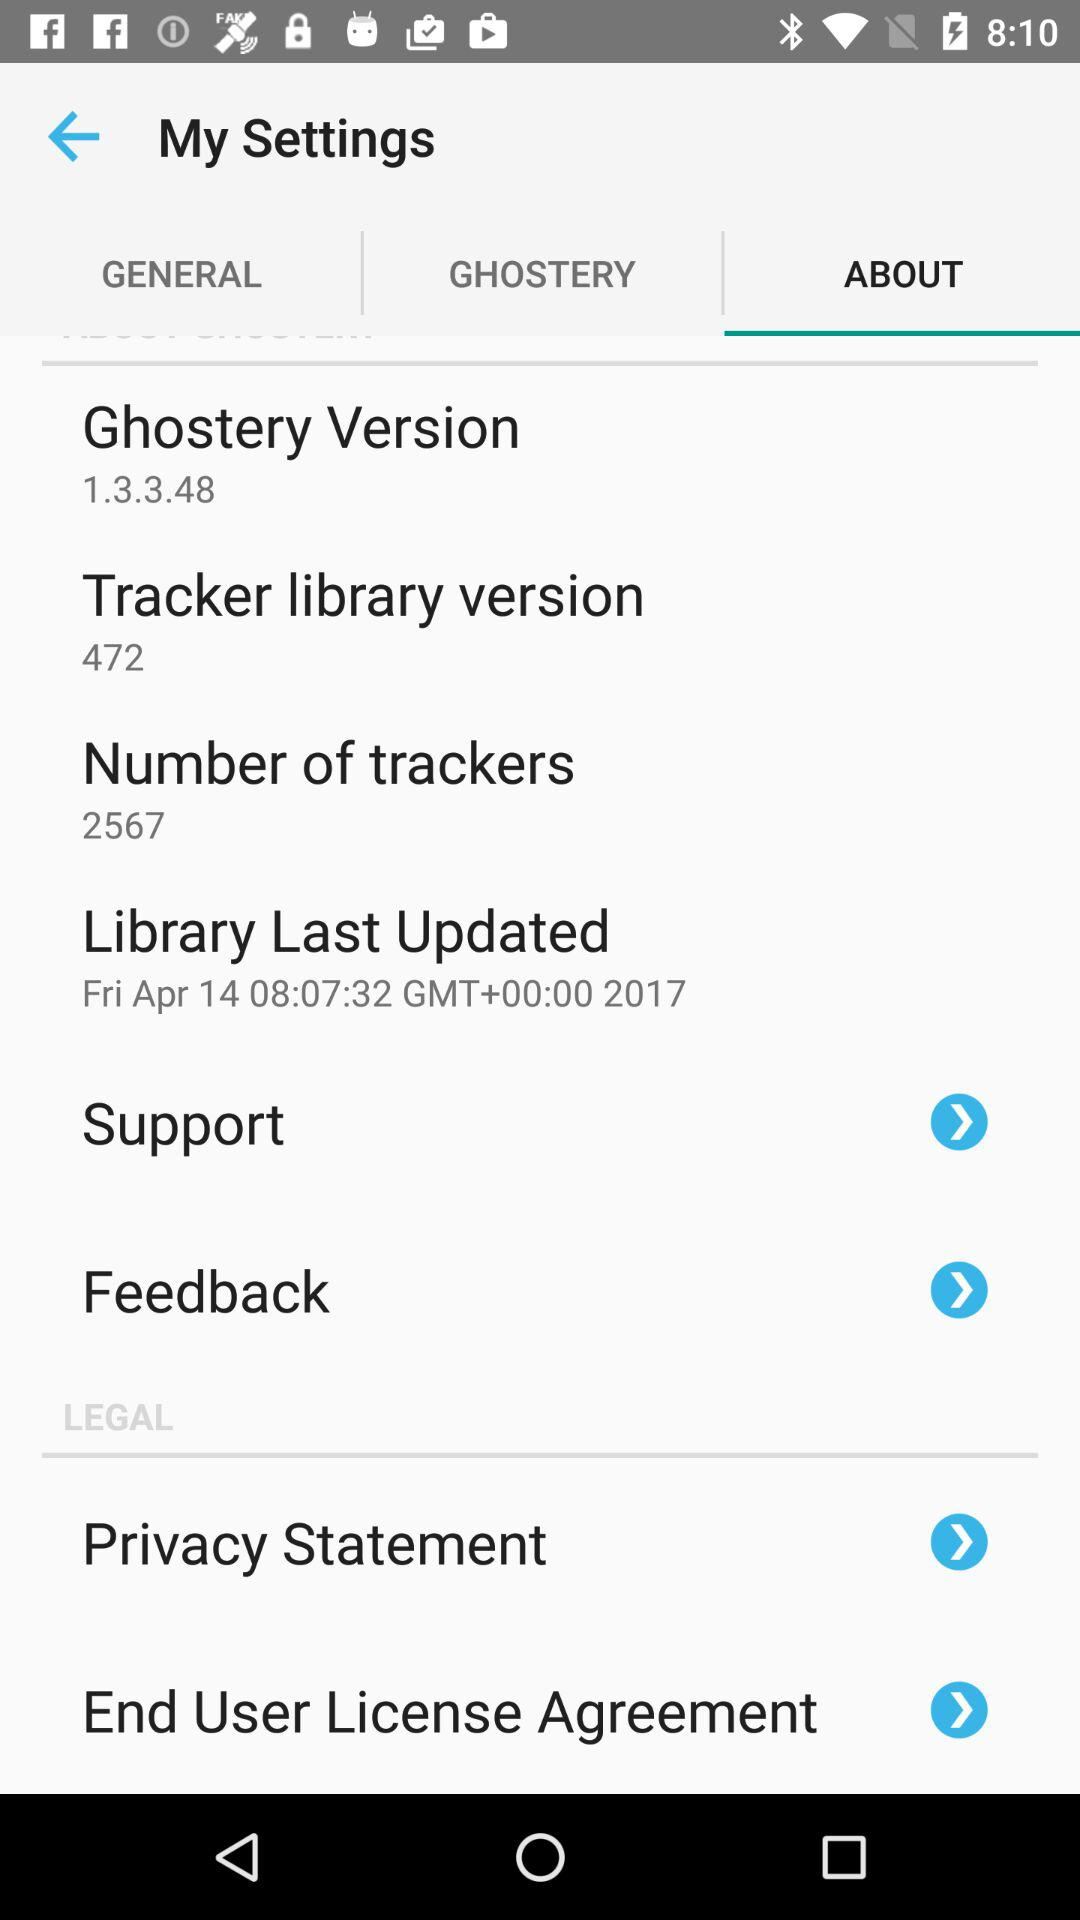What is the Ghostery version? The version is 1.3.3.48. 